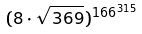Convert formula to latex. <formula><loc_0><loc_0><loc_500><loc_500>( 8 \cdot \sqrt { 3 6 9 } ) ^ { 1 6 6 ^ { 3 1 5 } }</formula> 